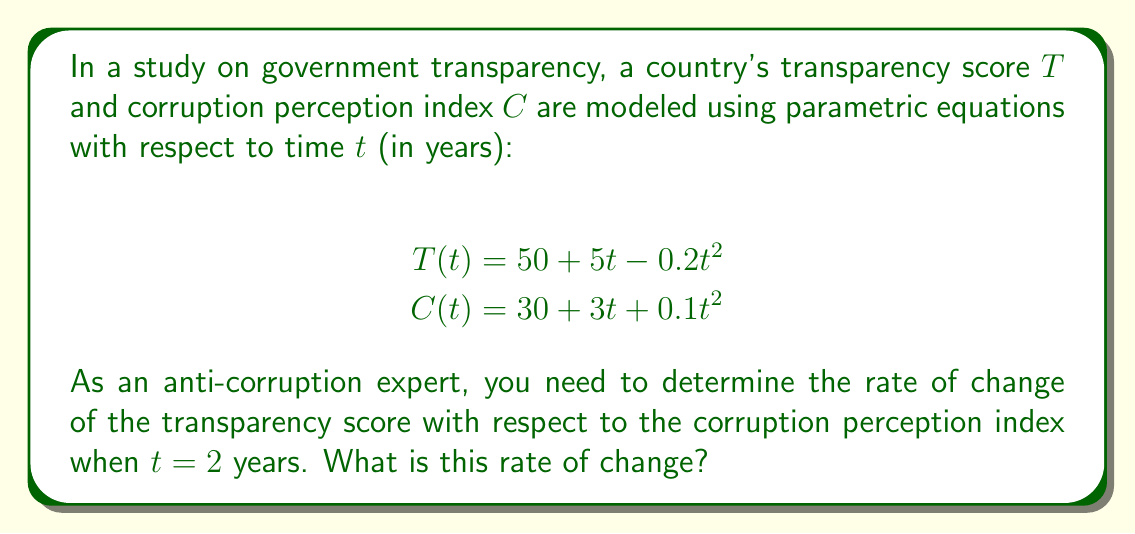Help me with this question. To find the rate of change of the transparency score with respect to the corruption perception index, we need to use the chain rule for parametric equations:

$$\frac{dT}{dC} = \frac{dT/dt}{dC/dt}$$

Step 1: Find $dT/dt$
$$T(t) = 50 + 5t - 0.2t^2$$
$$\frac{dT}{dt} = 5 - 0.4t$$

Step 2: Find $dC/dt$
$$C(t) = 30 + 3t + 0.1t^2$$
$$\frac{dC}{dt} = 3 + 0.2t$$

Step 3: Calculate $dT/dC$ using the chain rule
$$\frac{dT}{dC} = \frac{dT/dt}{dC/dt} = \frac{5 - 0.4t}{3 + 0.2t}$$

Step 4: Evaluate at $t = 2$
$$\frac{dT}{dC}\bigg|_{t=2} = \frac{5 - 0.4(2)}{3 + 0.2(2)} = \frac{5 - 0.8}{3 + 0.4} = \frac{4.2}{3.4} \approx 1.235$$

The rate of change is positive, indicating that as the corruption perception index increases, the transparency score also increases at this point in time.
Answer: $\frac{dT}{dC}\bigg|_{t=2} \approx 1.235$ 